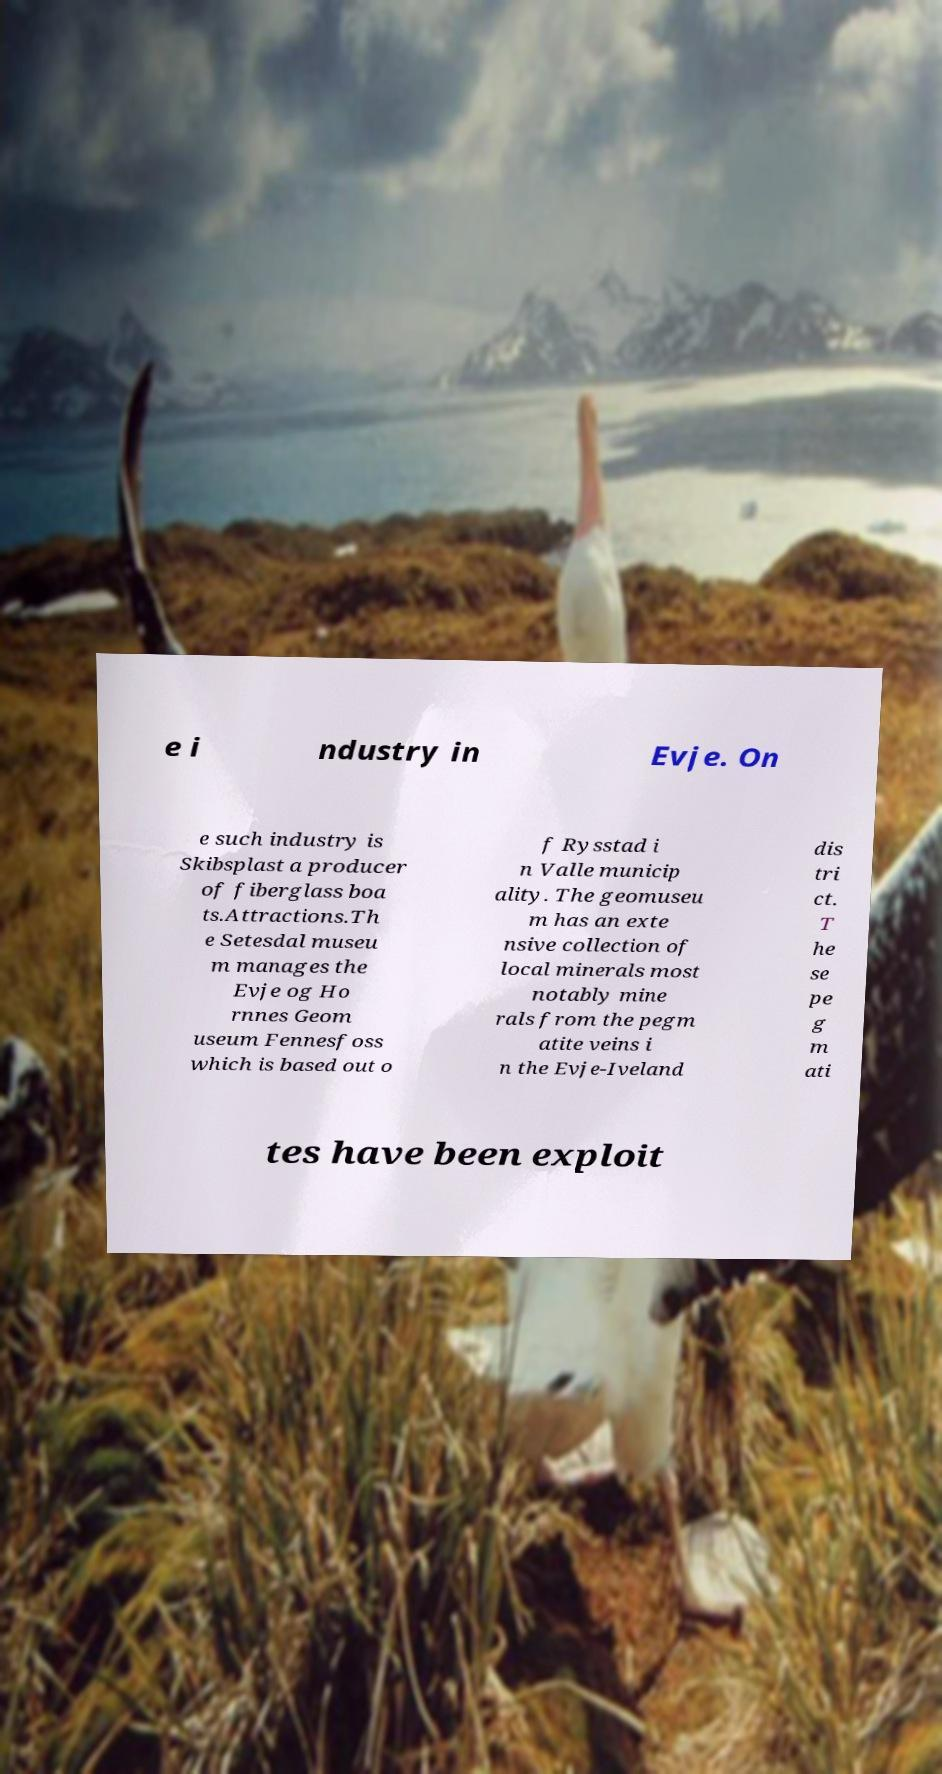Could you assist in decoding the text presented in this image and type it out clearly? e i ndustry in Evje. On e such industry is Skibsplast a producer of fiberglass boa ts.Attractions.Th e Setesdal museu m manages the Evje og Ho rnnes Geom useum Fennesfoss which is based out o f Rysstad i n Valle municip ality. The geomuseu m has an exte nsive collection of local minerals most notably mine rals from the pegm atite veins i n the Evje-Iveland dis tri ct. T he se pe g m ati tes have been exploit 